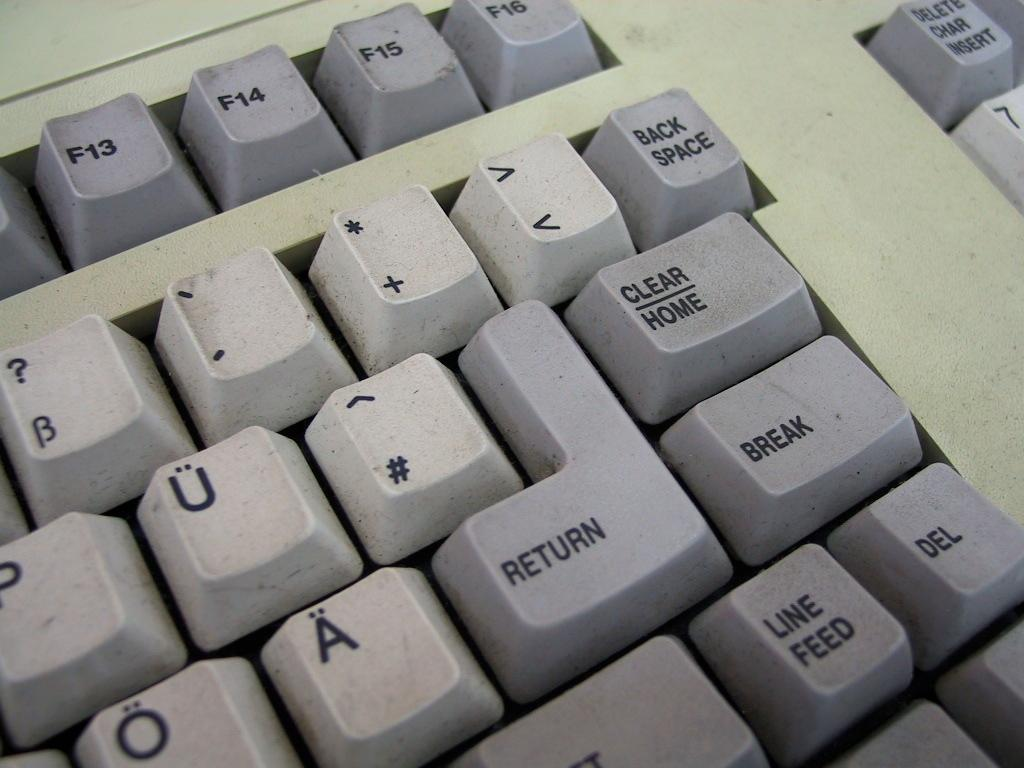<image>
Summarize the visual content of the image. White and grey keyboard keys with "backspace" on the top right. 